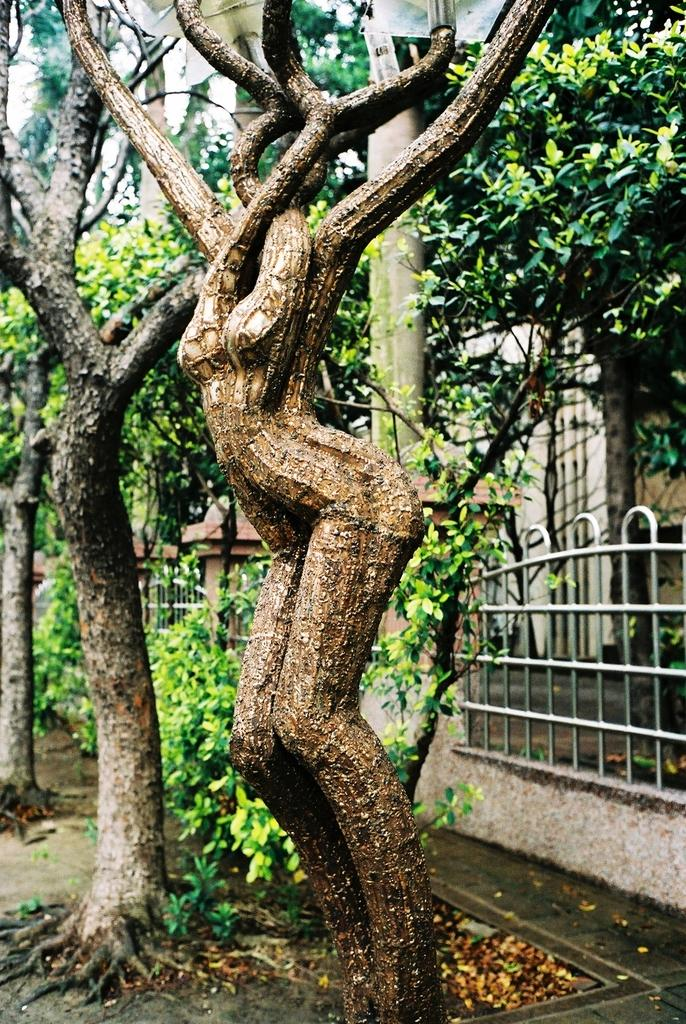What type of natural elements can be seen in the image? There are trees in the image. What can be seen on the right side of the image? There is a railing on the right side of the image. What type of man-made structures are visible in the background of the image? There are buildings in the background of the image. What type of animal can be seen interacting with the railing in the image? There is no animal present in the image; it only features trees, a railing, and buildings in the background. Where is the sink located in the image? There is no sink present in the image. 